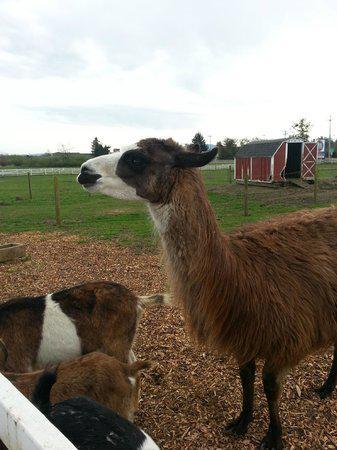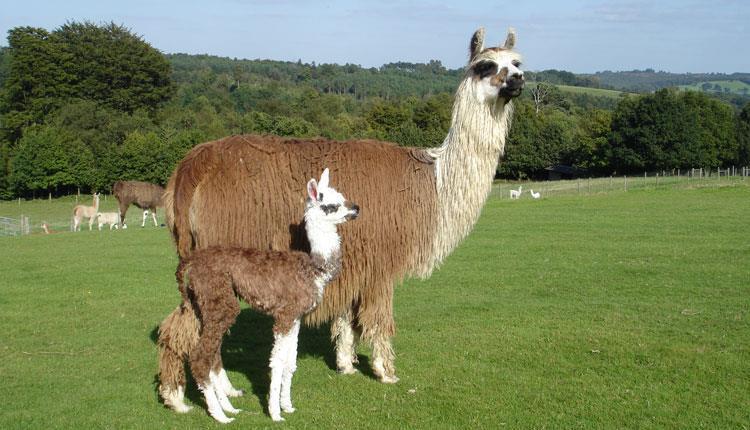The first image is the image on the left, the second image is the image on the right. For the images shown, is this caption "There are no more than two llamas." true? Answer yes or no. No. The first image is the image on the left, the second image is the image on the right. Analyze the images presented: Is the assertion "The llama in the foreground of the left image is standing with its body and head turned leftward, and the right image includes one young-looking llama with long legs who is standing in profile." valid? Answer yes or no. Yes. 